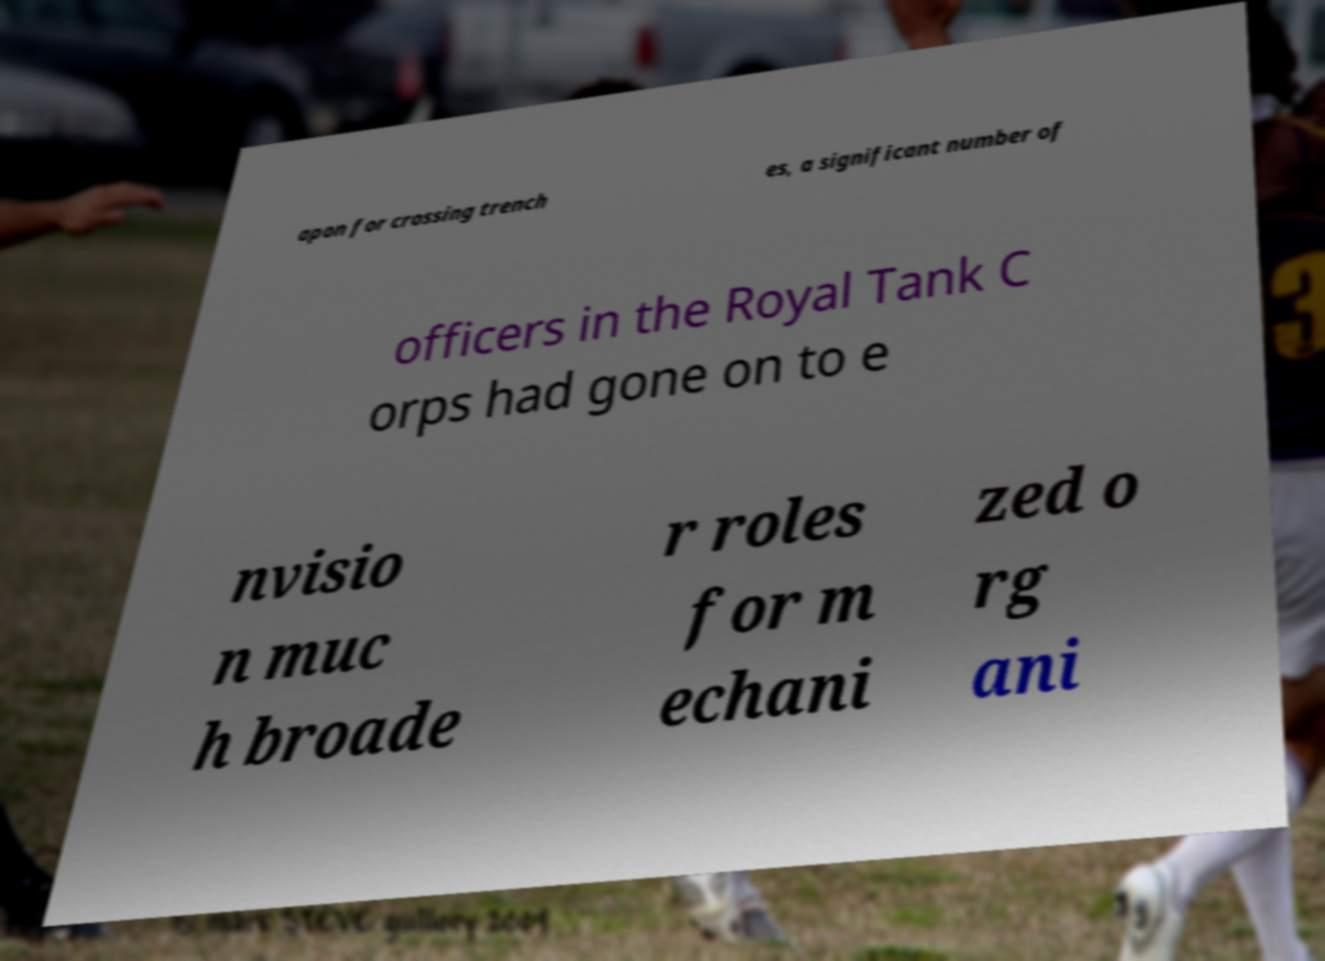There's text embedded in this image that I need extracted. Can you transcribe it verbatim? apon for crossing trench es, a significant number of officers in the Royal Tank C orps had gone on to e nvisio n muc h broade r roles for m echani zed o rg ani 